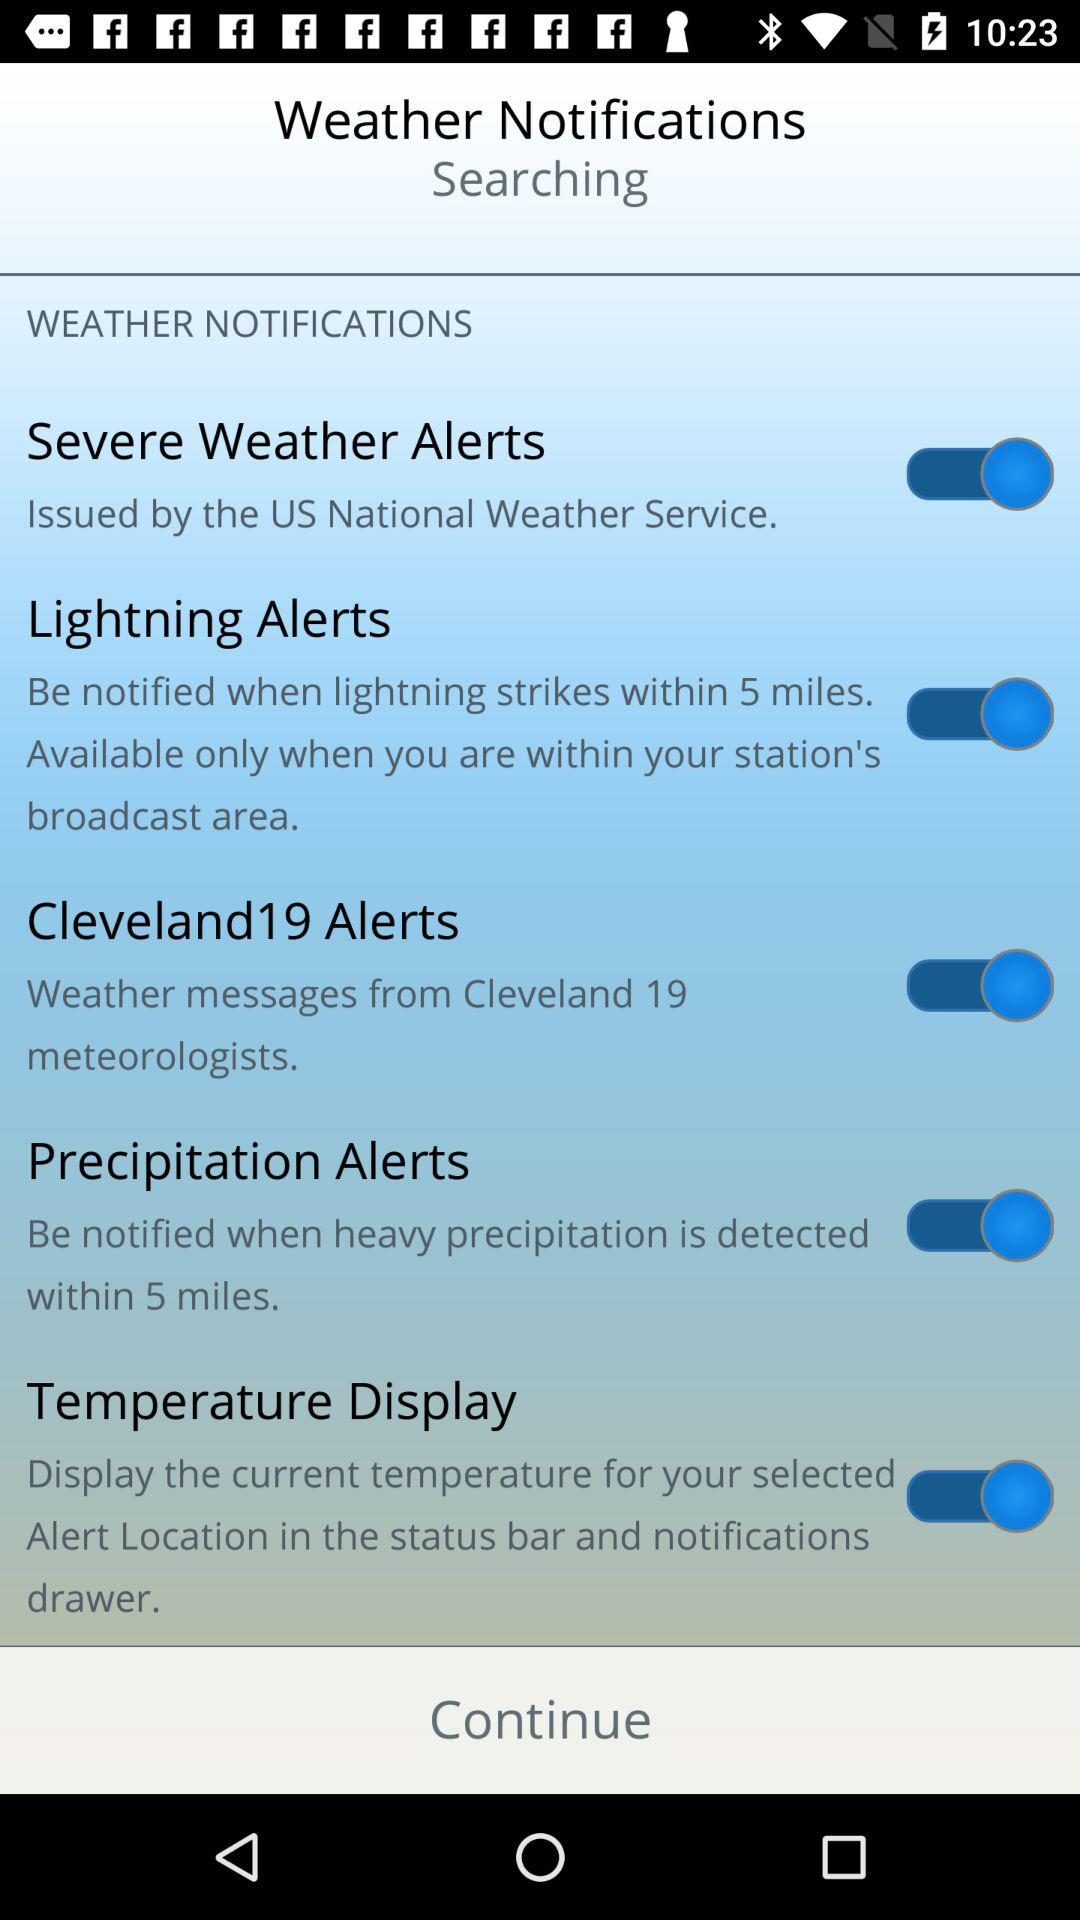What other types of weather notifications can be enabled on this system? Aside from 'Severe Weather Alerts,' you can enable 'Lightning Alerts,' 'Cleveland19 Alerts,' 'Precipitation Alerts,' and 'Temperature Display.' Each of these alerts can be toggled on to provide specific notifications such as lightning strikes nearby, messages from local meteorologists, detection of heavy precipitation, and real-time temperature updates for your location, respectively. 